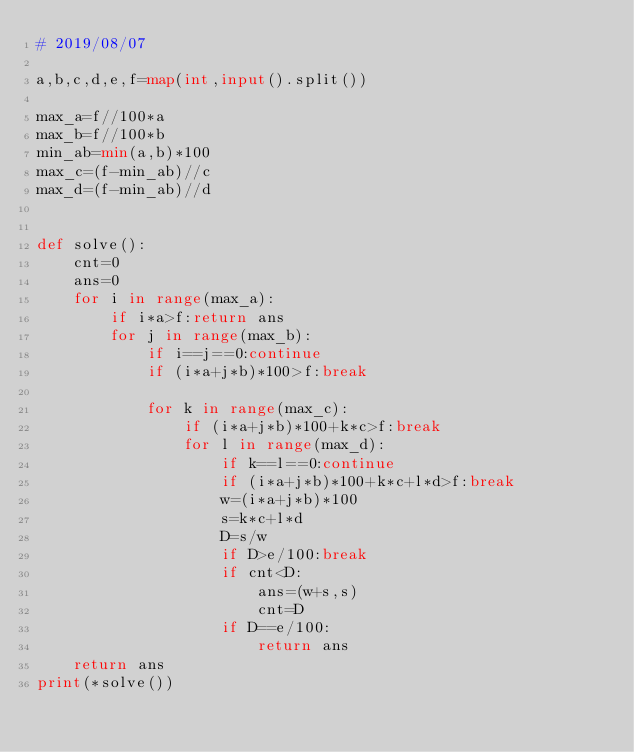<code> <loc_0><loc_0><loc_500><loc_500><_Python_># 2019/08/07

a,b,c,d,e,f=map(int,input().split())

max_a=f//100*a
max_b=f//100*b
min_ab=min(a,b)*100
max_c=(f-min_ab)//c
max_d=(f-min_ab)//d


def solve():
    cnt=0   
    ans=0   
    for i in range(max_a):
        if i*a>f:return ans
        for j in range(max_b):
            if i==j==0:continue
            if (i*a+j*b)*100>f:break

            for k in range(max_c):
                if (i*a+j*b)*100+k*c>f:break
                for l in range(max_d):
                    if k==l==0:continue
                    if (i*a+j*b)*100+k*c+l*d>f:break
                    w=(i*a+j*b)*100
                    s=k*c+l*d
                    D=s/w
                    if D>e/100:break
                    if cnt<D:
                        ans=(w+s,s)
                        cnt=D
                    if D==e/100:
                        return ans
    return ans
print(*solve())</code> 